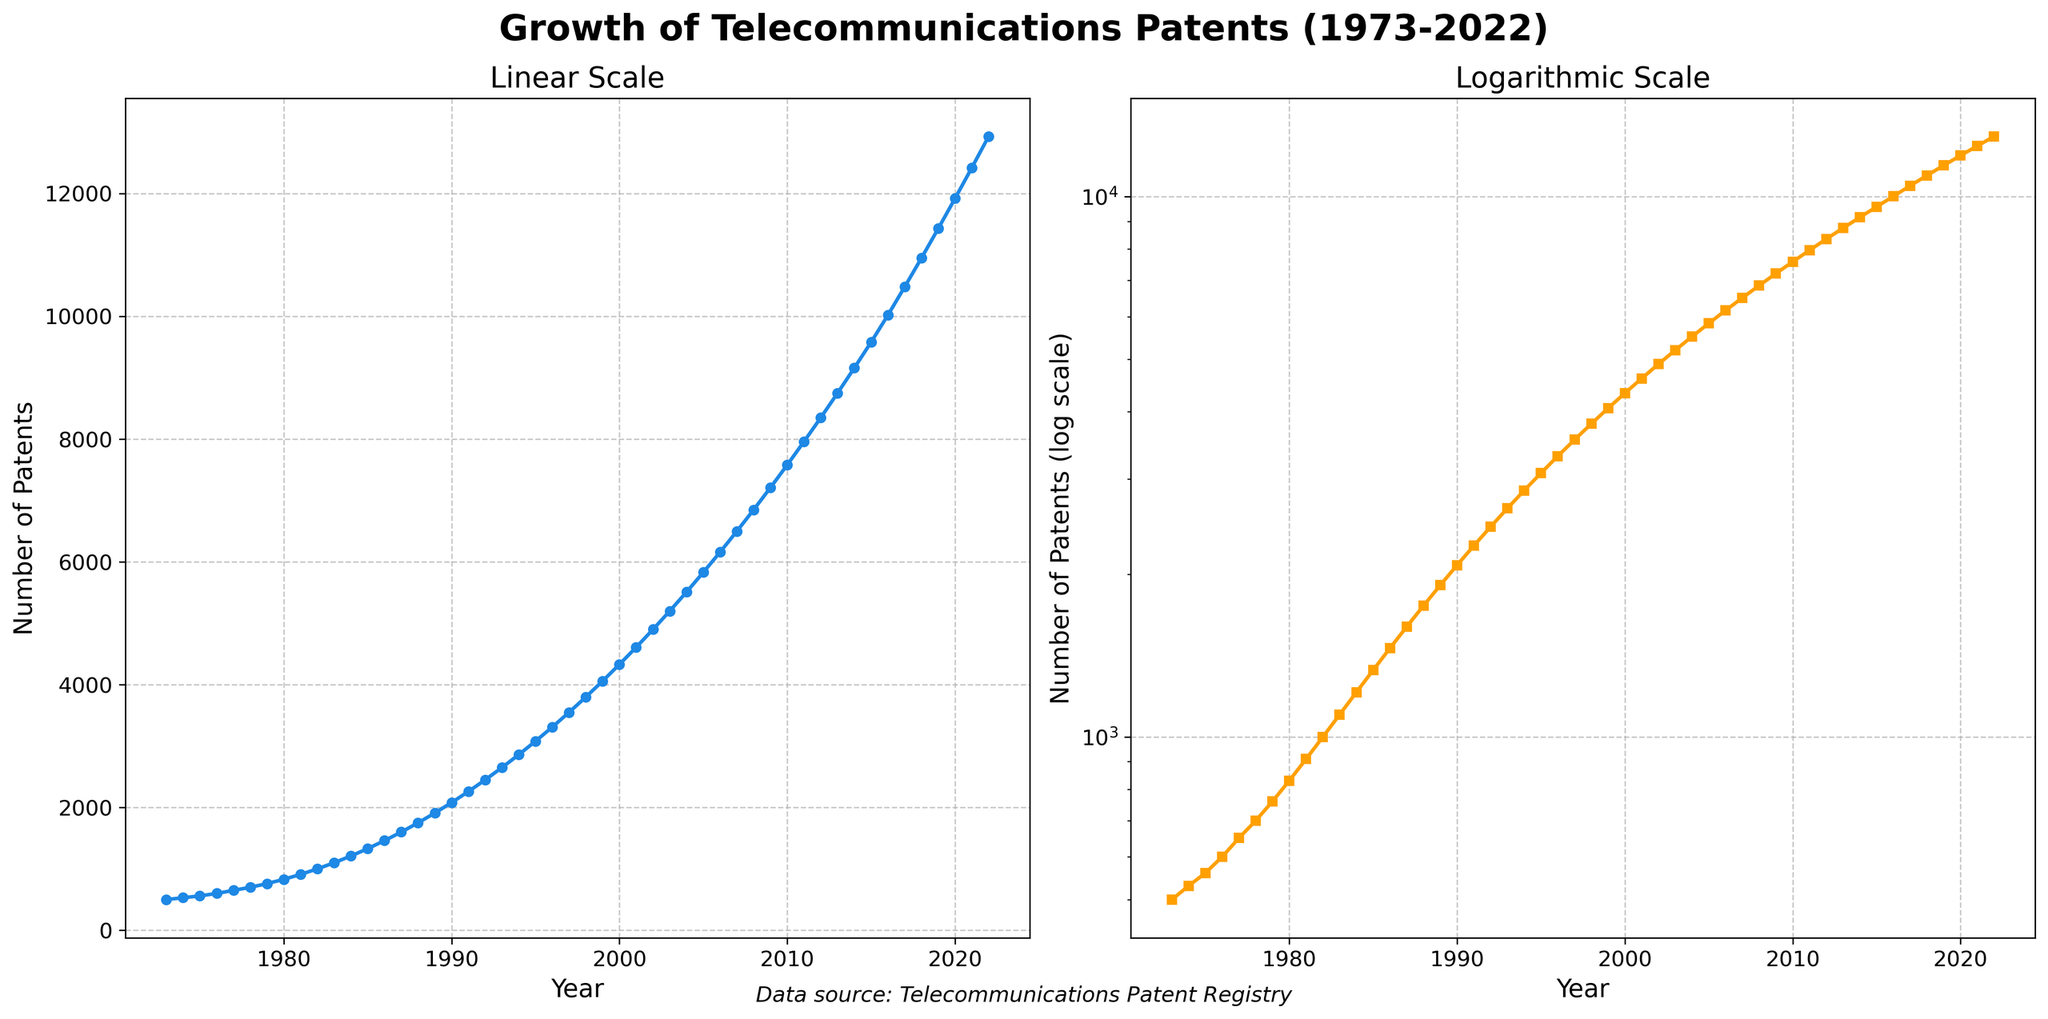How many subplots are in the figure? The figure features two subplots, as mentioned in the given code and can be observed from looking at the two separate graphs within the figure.
Answer: 2 What is the title of the left subplot? The title of the left subplot is evident from visual inspection. It is written above the subplot.
Answer: Linear Scale What scale does the right subplot use? The right subplot uses a logarithmic scale for the y-axis, as indicated by the labels and the plot's title.
Answer: Logarithmic What color is used for the data points in the left subplot? By looking at the figure, we can see that the data points in the left subplot are blue.
Answer: Blue How many patents were filed in 1990? Observing the data point corresponding to 1990 on either of the subplots, we can see the number of patents filed in 1990.
Answer: 2080 Between which years did the number of patents first exceed 10,000? By looking at the logarithmic scale in the right subplot, we can observe that the number of patents first exceeded 10,000 between the years 2015 and 2016.
Answer: 2015 and 2016 What is the trend in the number of patents filed over the years? Both subplots show a consistent upward trend in the number of patents filed over the years.
Answer: Increasing Which year saw the highest number of patents filed and what was the number? By looking at the highest point in the data, which is the last point on both subplots, we can determine that the highest number of patents filed was in 2022, with 12,930 patents.
Answer: 2022, 12,930 How does the growth rate observed in the left subplot compare to that in the right subplot? The linear scale on the left subplot shows a more visually pronounced increase, while the logarithmic scale on the right subplot shows a consistent logarithmic growth pattern, indicating exponential growth.
Answer: Exponential broader trend What is the average number of patents filed per year from 1973 to 2022? Sum up all the number of patents filed from 1973 to 2022 and divide by the number of years (50). Using the given data: (500+530+560+...+12930)/50 = 5817
Answer: 5817 